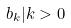Convert formula to latex. <formula><loc_0><loc_0><loc_500><loc_500>b _ { k } | k > 0</formula> 